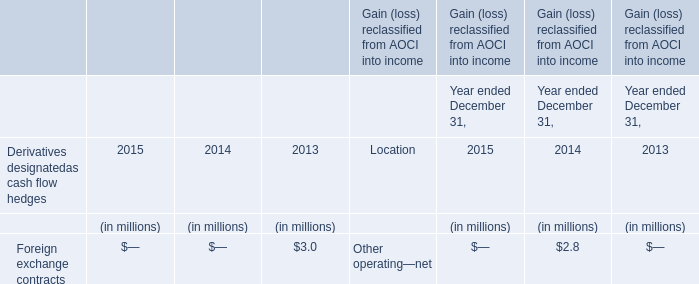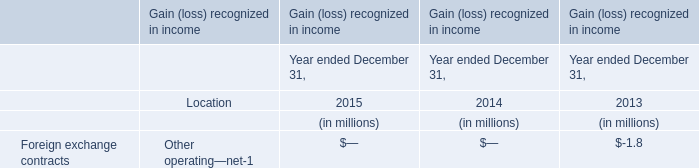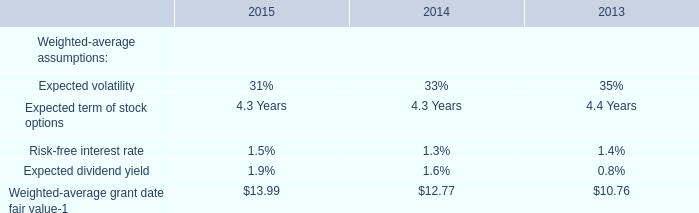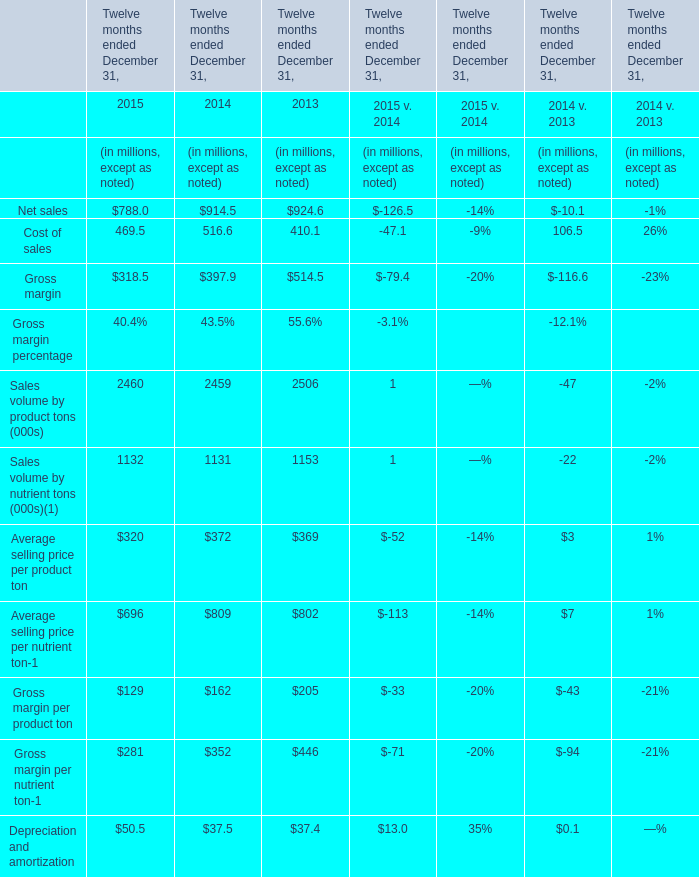What is the average value of Gross margin percentage in Table 3 and Other operating—net of Foreign exchange contracts in Table 1 in 2013? (in million) 
Computations: ((514.5 - 1.8) / 2)
Answer: 256.35. 